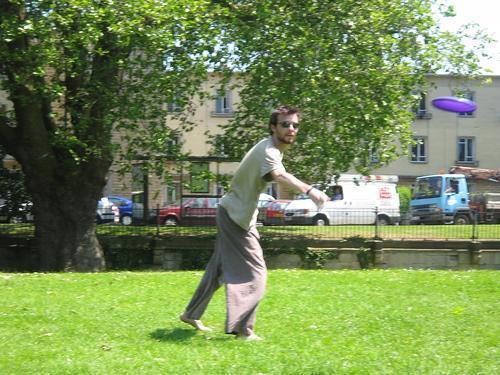How many trucks are there?
Give a very brief answer. 1. 